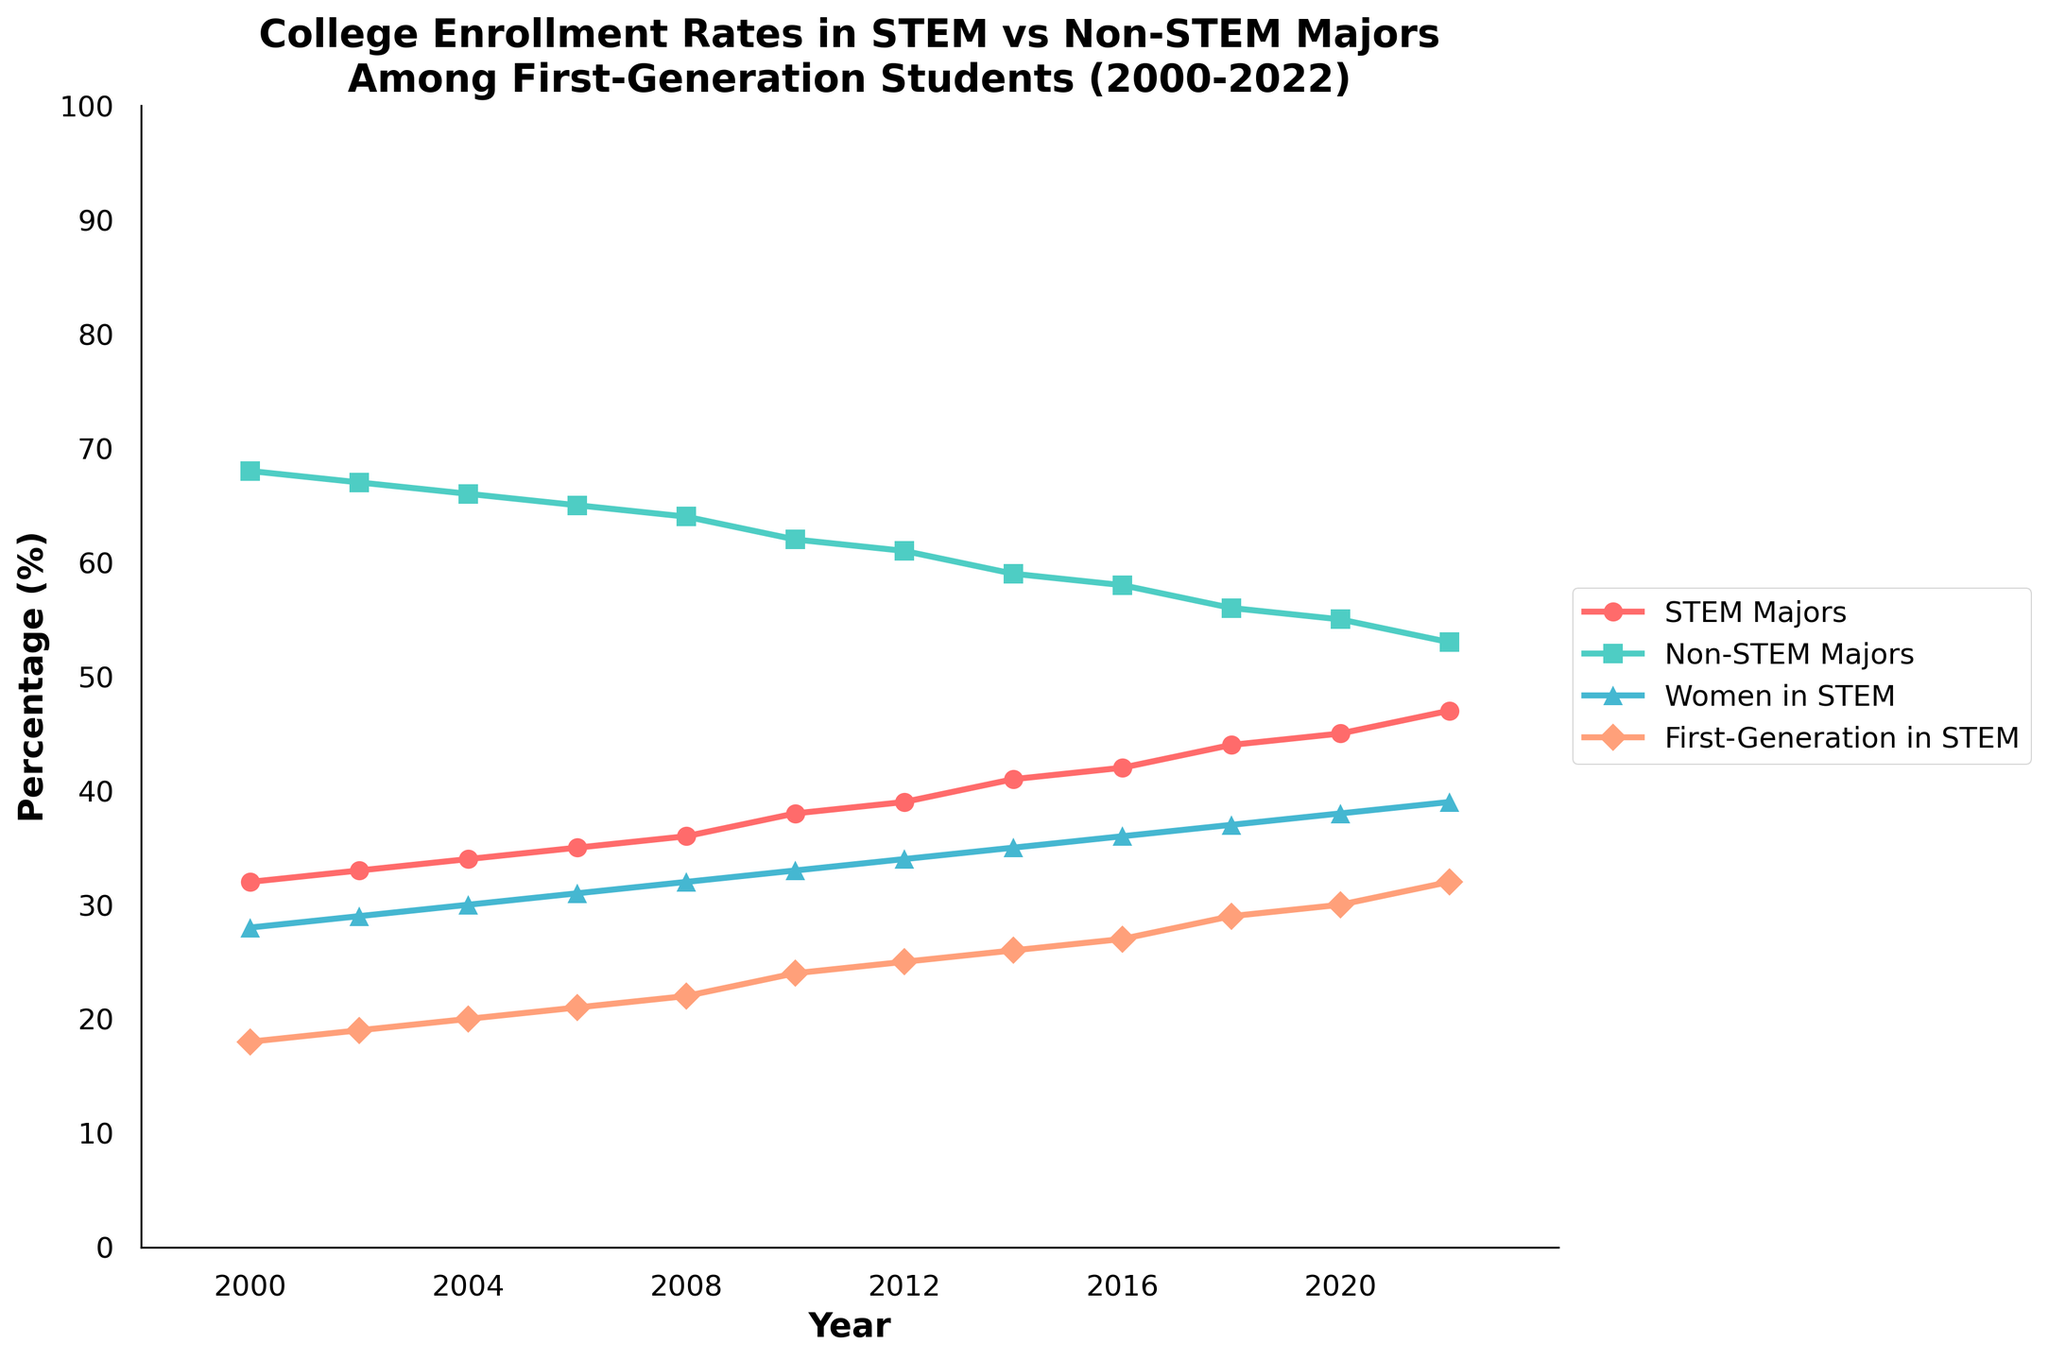What is the trend in the percentage of first-generation students in STEM majors from 2000 to 2022? From 2000 to 2022, the percentage of first-generation students in STEM majors shows an increasing trend. It starts at 18% in 2000 and gradually rises to 32% in 2022.
Answer: Increasing trend How does the percentage of non-STEM majors in 2010 compare to the percentage of STEM majors in the same year? In 2010, the percentage of non-STEM majors is 62%, while the percentage of STEM majors is 38%. Comparing the two, non-STEM majors have a higher percentage.
Answer: Non-STEM majors have a higher percentage What is the average percentage of women in STEM majors over the years 2000 to 2010? To find the average percentage of women in STEM over the years 2000 to 2010, sum the percentages for each year (28 + 29 + 30 + 31 + 32 + 33) and divide by the number of years (6). The sum is 183, so the average is 183 / 6 = 30.5%.
Answer: 30.5% What year sees a crossover point where STEM majors become more than 40% of enrollments? To find the crossover point, we look at the trend line for STEM majors. The year when STEM majors exceed 40% is 2014.
Answer: 2014 Which segment shows the highest increase in percentage over the entire period (2000-2022)? Comparing the segments: STEM Majors increased from 32% to 47% (+15%), Non-STEM Majors decreased from 68% to 53% (-15%), Women in STEM from 28% to 39% (+11%), and First-Generation in STEM from 18% to 32% (+14%). STEM Majors show the highest increase (15%).
Answer: STEM Majors By how many percentage points did the percentage of non-STEM majors drop from 2000 to 2022? The percentage of non-STEM majors dropped from 68% in 2000 to 53% in 2022. The difference is 68% - 53% = 15 percentage points.
Answer: 15 percentage points Which year shows the highest percentage of women in STEM majors, and what is the percentage? The highest percentage of women in STEM majors is seen in 2022 at 39%.
Answer: 2022, 39% If you combine the percentages of women in STEM and first-generation students in STEM in 2008, what is their total? In 2008, women in STEM is 32% and first-generation in STEM is 22%. Their combined total is 32% + 22% = 54%.
Answer: 54% In which year did the percentage of first-generation students in STEM majors become equal to or surpass the percentage of STEM Majors in 2000? The percentage of first-generation students in STEM majors in 2020 is 30%, which is equal to the percentage of STEM majors in 2000.
Answer: 2020 